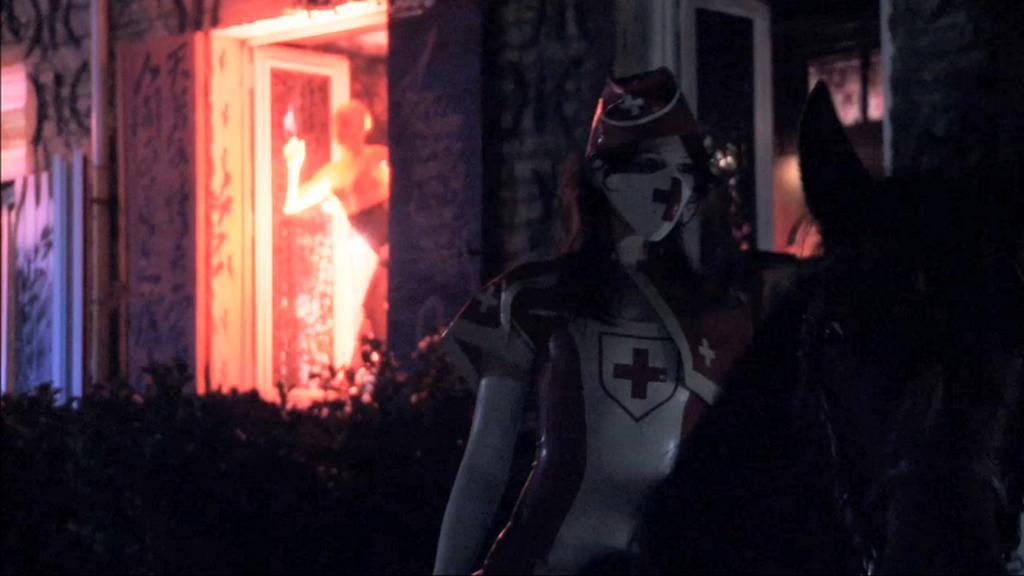Describe this image in one or two sentences. In this image, I can see the woman sitting on the horse. I think she wore a fancy dress. I can see the plants. This looks like a door. I think this is a statue. This is a building. I can see a pipe attached to the building wall. 